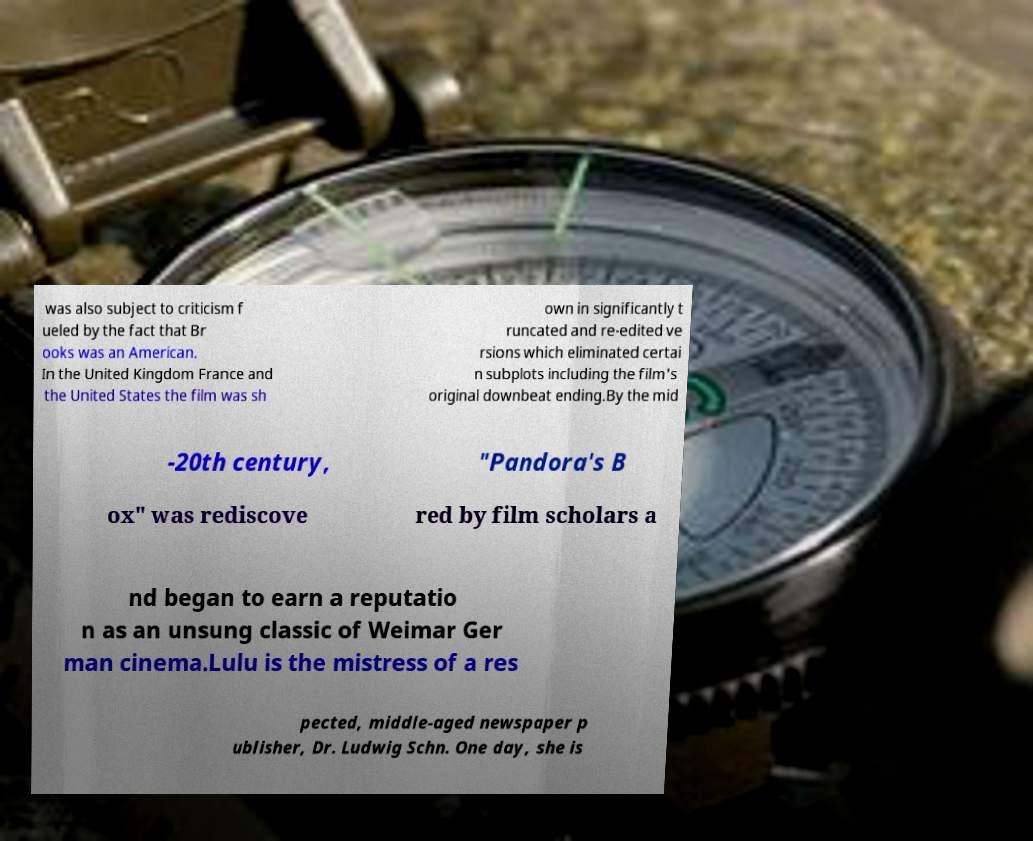Could you assist in decoding the text presented in this image and type it out clearly? was also subject to criticism f ueled by the fact that Br ooks was an American. In the United Kingdom France and the United States the film was sh own in significantly t runcated and re-edited ve rsions which eliminated certai n subplots including the film's original downbeat ending.By the mid -20th century, "Pandora's B ox" was rediscove red by film scholars a nd began to earn a reputatio n as an unsung classic of Weimar Ger man cinema.Lulu is the mistress of a res pected, middle-aged newspaper p ublisher, Dr. Ludwig Schn. One day, she is 